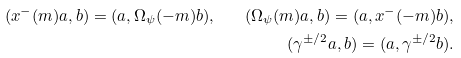<formula> <loc_0><loc_0><loc_500><loc_500>( x ^ { - } ( m ) a , b ) = ( a , \Omega _ { \psi } ( - m ) b ) , \quad ( \Omega _ { \psi } ( m ) a , b ) = ( a , x ^ { - } ( - m ) b ) , \\ ( \gamma ^ { \pm / 2 } a , b ) = ( a , \gamma ^ { \pm / 2 } b ) .</formula> 